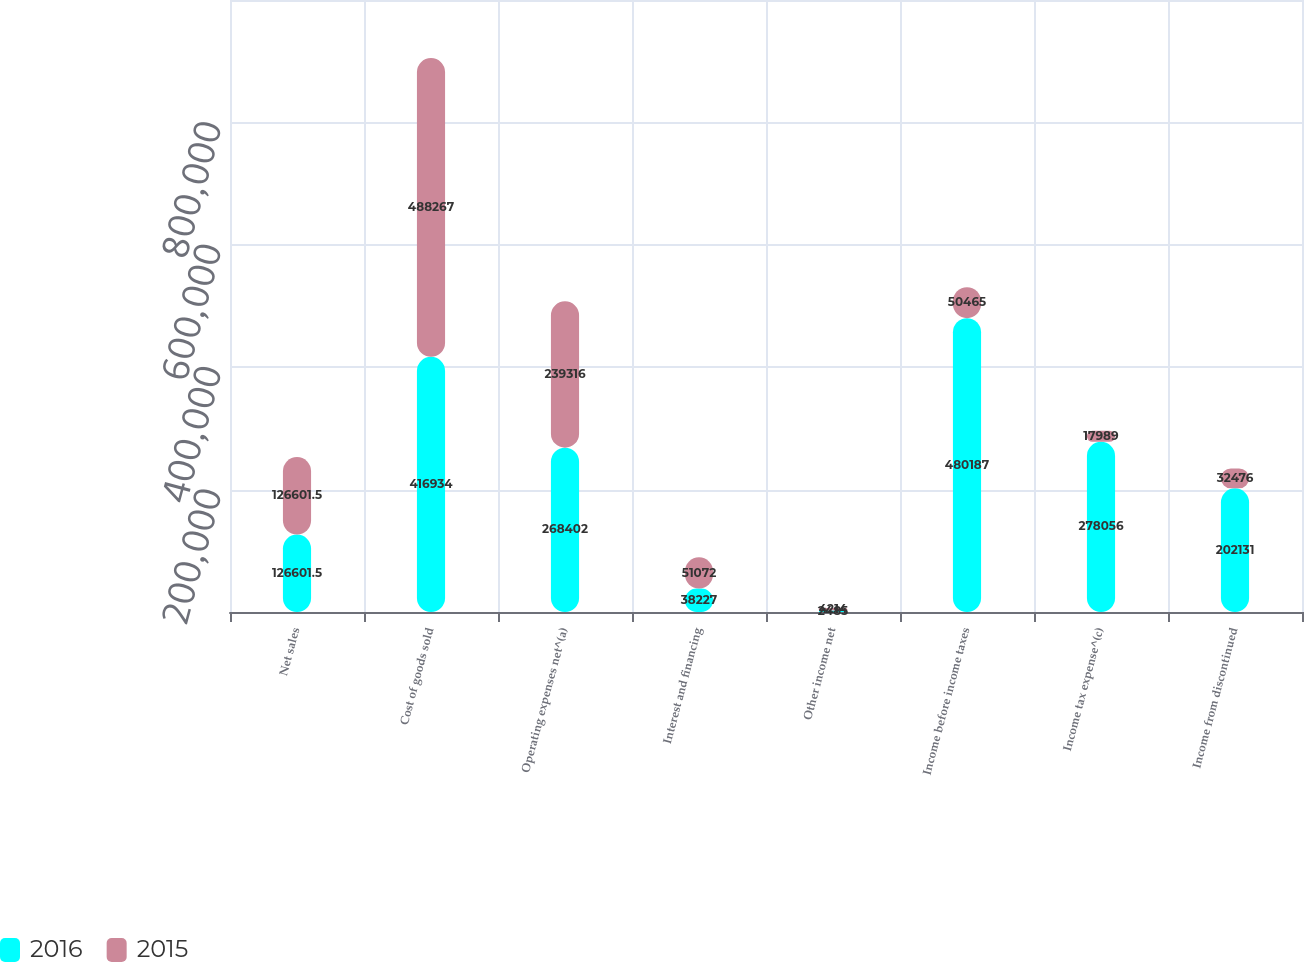Convert chart. <chart><loc_0><loc_0><loc_500><loc_500><stacked_bar_chart><ecel><fcel>Net sales<fcel>Cost of goods sold<fcel>Operating expenses net^(a)<fcel>Interest and financing<fcel>Other income net<fcel>Income before income taxes<fcel>Income tax expense^(c)<fcel>Income from discontinued<nl><fcel>2016<fcel>126602<fcel>416934<fcel>268402<fcel>38227<fcel>2485<fcel>480187<fcel>278056<fcel>202131<nl><fcel>2015<fcel>126602<fcel>488267<fcel>239316<fcel>51072<fcel>4214<fcel>50465<fcel>17989<fcel>32476<nl></chart> 